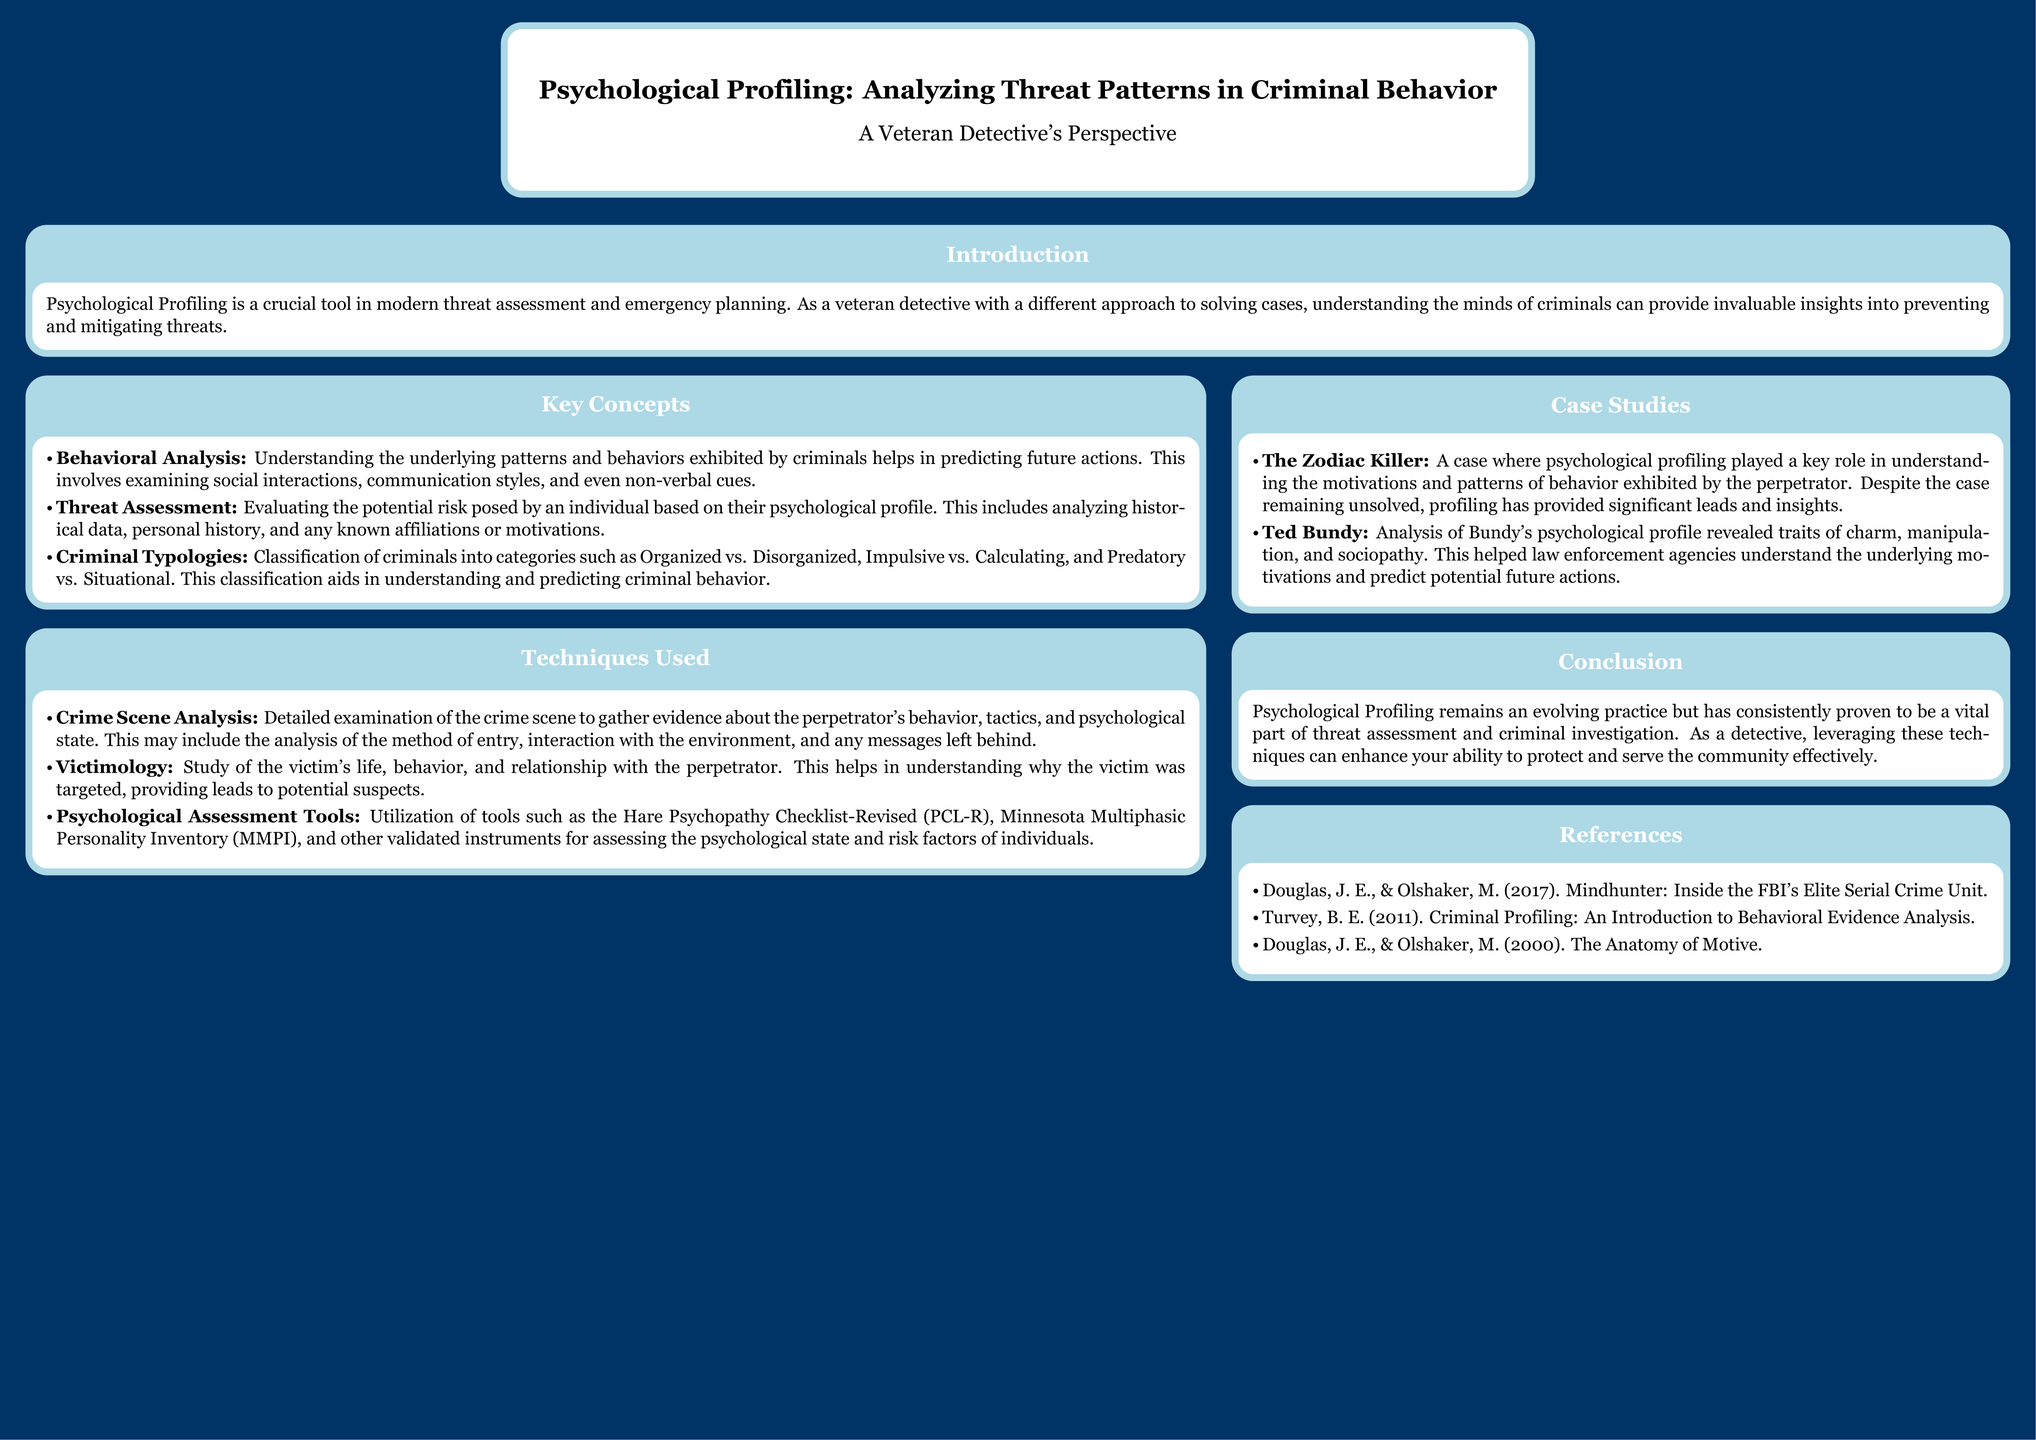What is the title of the poster? The title of the poster is presented prominently at the top of the document.
Answer: Psychological Profiling: Analyzing Threat Patterns in Criminal Behavior Who is the author of the poster? The author's name is listed below the title of the poster.
Answer: A Veteran Detective's Perspective What type of analysis helps predict future actions of criminals? The specific type of analysis is mentioned in the "Key Concepts" section as crucial for understanding criminal behavior.
Answer: Behavioral Analysis Which checklist is mentioned as a psychological assessment tool? The specific checklist mentioned in the "Techniques Used" section is recognizable as a notable tool.
Answer: Hare Psychopathy Checklist-Revised (PCL-R) What case is highlighted to demonstrate the use of psychological profiling? A notable case is cited in the "Case Studies" section to illustrate the application of profiling in investigations.
Answer: The Zodiac Killer What is the primary focus of Victimology? The focus of this study is provided clearly in the "Techniques Used" section regarding understanding victims.
Answer: Study of the victim's life How many key concepts are listed in the poster? The number of key concepts can be counted in the "Key Concepts" section.
Answer: Three What year was “Criminal Profiling: An Introduction to Behavioral Evidence Analysis” published? The publication year of this reference can be found in the "References" section of the poster.
Answer: 2011 What does the poster suggest is an evolving practice? The conclusion provides insights into the nature of the practice being discussed in the document.
Answer: Psychological Profiling 